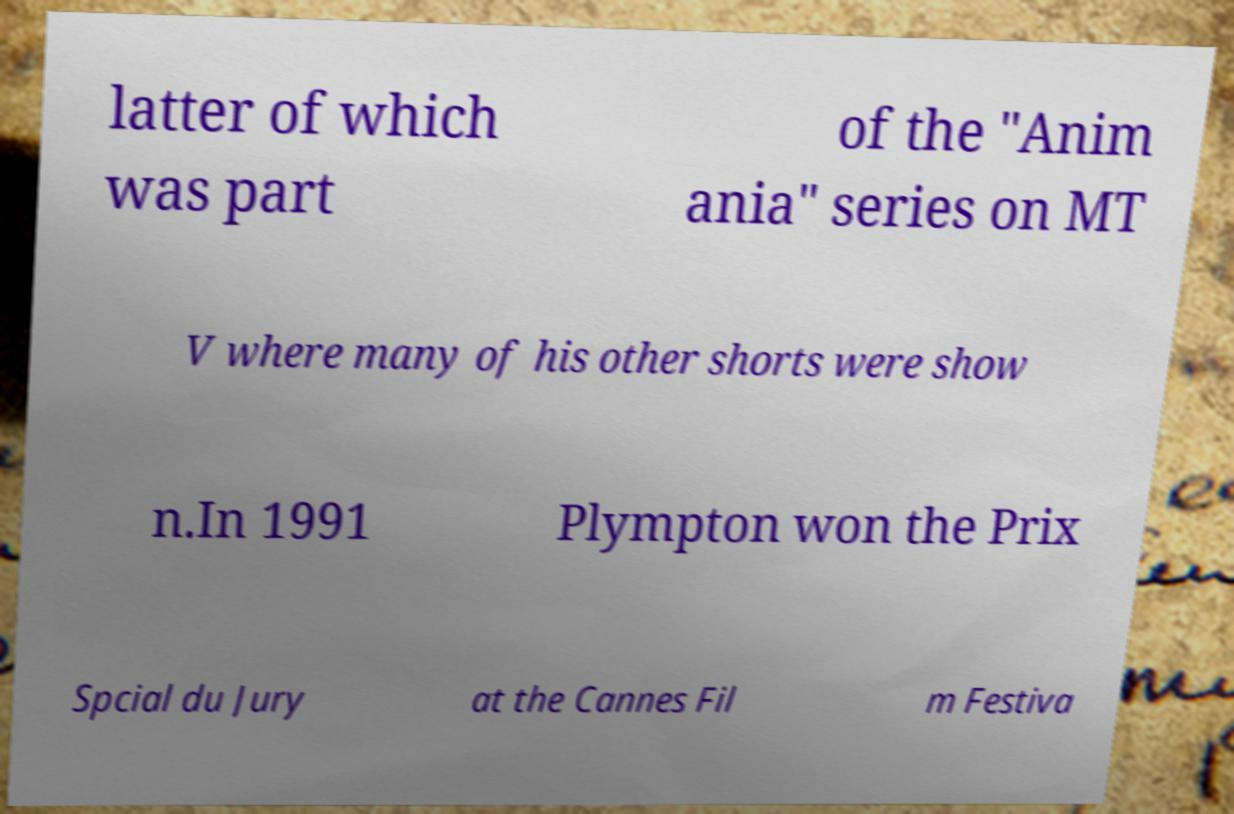What messages or text are displayed in this image? I need them in a readable, typed format. latter of which was part of the "Anim ania" series on MT V where many of his other shorts were show n.In 1991 Plympton won the Prix Spcial du Jury at the Cannes Fil m Festiva 